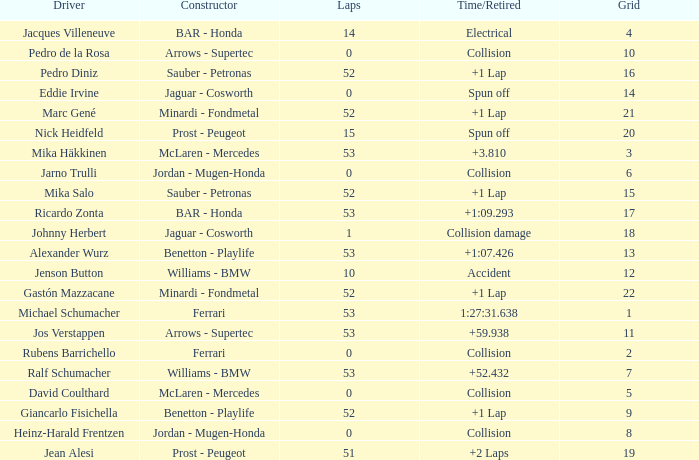How many laps did Ricardo Zonta have? 53.0. 